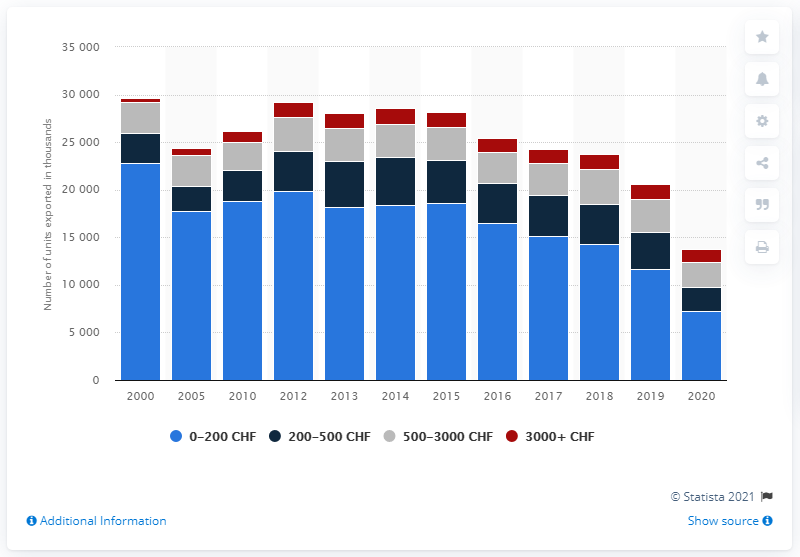Give some essential details in this illustration. In 2020, a total of 7,203 units of Swiss watches were exported worldwide. 